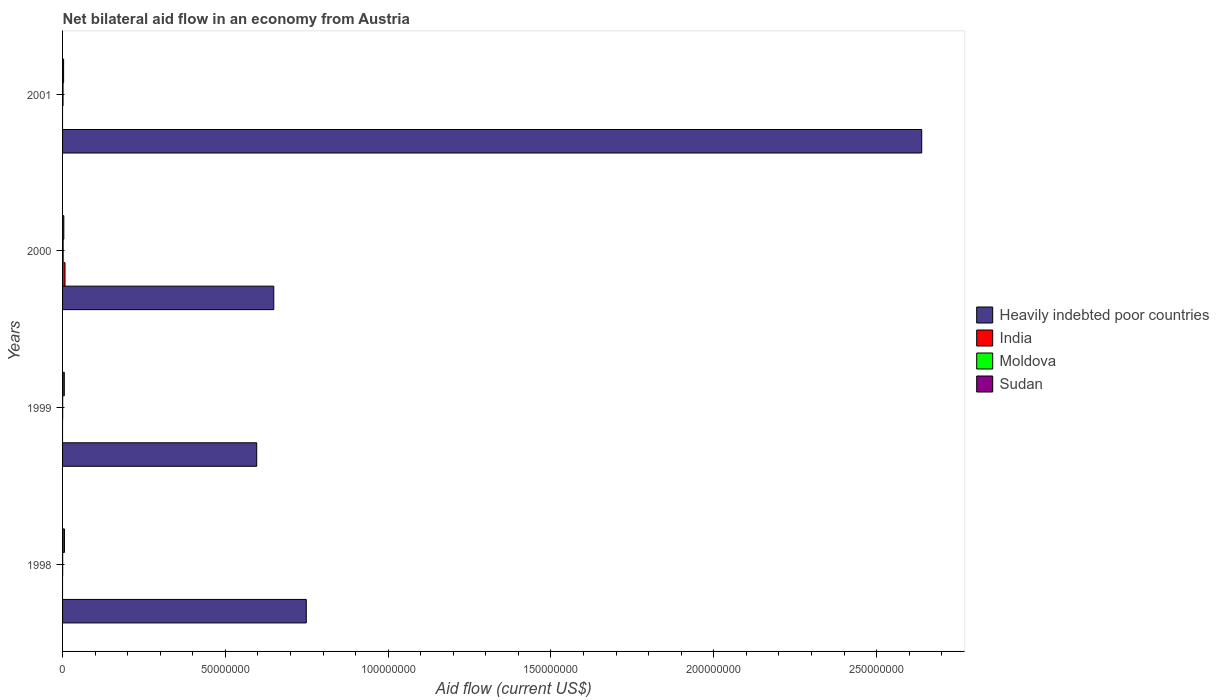How many groups of bars are there?
Your answer should be compact. 4. How many bars are there on the 2nd tick from the bottom?
Keep it short and to the point. 3. What is the net bilateral aid flow in Sudan in 1999?
Give a very brief answer. 5.30e+05. Across all years, what is the maximum net bilateral aid flow in Sudan?
Offer a very short reply. 5.80e+05. Across all years, what is the minimum net bilateral aid flow in Sudan?
Your answer should be compact. 3.20e+05. What is the total net bilateral aid flow in India in the graph?
Keep it short and to the point. 7.50e+05. What is the difference between the net bilateral aid flow in Moldova in 1998 and that in 1999?
Provide a short and direct response. 0. What is the difference between the net bilateral aid flow in Heavily indebted poor countries in 2000 and the net bilateral aid flow in India in 1999?
Your answer should be very brief. 6.49e+07. What is the average net bilateral aid flow in Moldova per year?
Your answer should be very brief. 9.75e+04. In the year 2000, what is the difference between the net bilateral aid flow in India and net bilateral aid flow in Sudan?
Keep it short and to the point. 3.60e+05. In how many years, is the net bilateral aid flow in Moldova greater than 10000000 US$?
Your response must be concise. 0. What is the ratio of the net bilateral aid flow in Moldova in 1998 to that in 2001?
Provide a succinct answer. 0.2. What is the difference between the highest and the lowest net bilateral aid flow in Sudan?
Provide a succinct answer. 2.60e+05. Is the sum of the net bilateral aid flow in Moldova in 1999 and 2001 greater than the maximum net bilateral aid flow in Heavily indebted poor countries across all years?
Offer a very short reply. No. Is it the case that in every year, the sum of the net bilateral aid flow in Sudan and net bilateral aid flow in Heavily indebted poor countries is greater than the sum of net bilateral aid flow in India and net bilateral aid flow in Moldova?
Offer a terse response. Yes. How many bars are there?
Offer a terse response. 13. What is the difference between two consecutive major ticks on the X-axis?
Ensure brevity in your answer.  5.00e+07. Are the values on the major ticks of X-axis written in scientific E-notation?
Your answer should be very brief. No. Does the graph contain any zero values?
Offer a terse response. Yes. Does the graph contain grids?
Ensure brevity in your answer.  No. Where does the legend appear in the graph?
Your answer should be compact. Center right. How are the legend labels stacked?
Offer a terse response. Vertical. What is the title of the graph?
Keep it short and to the point. Net bilateral aid flow in an economy from Austria. Does "Lower middle income" appear as one of the legend labels in the graph?
Make the answer very short. No. What is the label or title of the X-axis?
Provide a short and direct response. Aid flow (current US$). What is the label or title of the Y-axis?
Make the answer very short. Years. What is the Aid flow (current US$) in Heavily indebted poor countries in 1998?
Give a very brief answer. 7.48e+07. What is the Aid flow (current US$) of India in 1998?
Your answer should be compact. 0. What is the Aid flow (current US$) of Sudan in 1998?
Ensure brevity in your answer.  5.80e+05. What is the Aid flow (current US$) in Heavily indebted poor countries in 1999?
Keep it short and to the point. 5.96e+07. What is the Aid flow (current US$) in India in 1999?
Provide a succinct answer. 0. What is the Aid flow (current US$) of Moldova in 1999?
Keep it short and to the point. 3.00e+04. What is the Aid flow (current US$) of Sudan in 1999?
Your answer should be compact. 5.30e+05. What is the Aid flow (current US$) in Heavily indebted poor countries in 2000?
Keep it short and to the point. 6.49e+07. What is the Aid flow (current US$) of India in 2000?
Your answer should be compact. 7.50e+05. What is the Aid flow (current US$) of Moldova in 2000?
Ensure brevity in your answer.  1.80e+05. What is the Aid flow (current US$) of Sudan in 2000?
Offer a very short reply. 3.90e+05. What is the Aid flow (current US$) of Heavily indebted poor countries in 2001?
Your answer should be very brief. 2.64e+08. What is the Aid flow (current US$) of Sudan in 2001?
Provide a succinct answer. 3.20e+05. Across all years, what is the maximum Aid flow (current US$) of Heavily indebted poor countries?
Your answer should be compact. 2.64e+08. Across all years, what is the maximum Aid flow (current US$) of India?
Offer a terse response. 7.50e+05. Across all years, what is the maximum Aid flow (current US$) of Sudan?
Provide a short and direct response. 5.80e+05. Across all years, what is the minimum Aid flow (current US$) of Heavily indebted poor countries?
Provide a short and direct response. 5.96e+07. Across all years, what is the minimum Aid flow (current US$) in India?
Offer a very short reply. 0. Across all years, what is the minimum Aid flow (current US$) of Sudan?
Ensure brevity in your answer.  3.20e+05. What is the total Aid flow (current US$) in Heavily indebted poor countries in the graph?
Offer a terse response. 4.63e+08. What is the total Aid flow (current US$) of India in the graph?
Ensure brevity in your answer.  7.50e+05. What is the total Aid flow (current US$) of Sudan in the graph?
Keep it short and to the point. 1.82e+06. What is the difference between the Aid flow (current US$) of Heavily indebted poor countries in 1998 and that in 1999?
Your answer should be very brief. 1.52e+07. What is the difference between the Aid flow (current US$) in Moldova in 1998 and that in 1999?
Provide a succinct answer. 0. What is the difference between the Aid flow (current US$) in Heavily indebted poor countries in 1998 and that in 2000?
Make the answer very short. 9.98e+06. What is the difference between the Aid flow (current US$) of Moldova in 1998 and that in 2000?
Your answer should be very brief. -1.50e+05. What is the difference between the Aid flow (current US$) in Heavily indebted poor countries in 1998 and that in 2001?
Your answer should be very brief. -1.89e+08. What is the difference between the Aid flow (current US$) in Moldova in 1998 and that in 2001?
Ensure brevity in your answer.  -1.20e+05. What is the difference between the Aid flow (current US$) in Heavily indebted poor countries in 1999 and that in 2000?
Offer a very short reply. -5.24e+06. What is the difference between the Aid flow (current US$) in Heavily indebted poor countries in 1999 and that in 2001?
Offer a very short reply. -2.04e+08. What is the difference between the Aid flow (current US$) in Moldova in 1999 and that in 2001?
Your answer should be compact. -1.20e+05. What is the difference between the Aid flow (current US$) in Heavily indebted poor countries in 2000 and that in 2001?
Offer a very short reply. -1.99e+08. What is the difference between the Aid flow (current US$) of Moldova in 2000 and that in 2001?
Keep it short and to the point. 3.00e+04. What is the difference between the Aid flow (current US$) of Heavily indebted poor countries in 1998 and the Aid flow (current US$) of Moldova in 1999?
Keep it short and to the point. 7.48e+07. What is the difference between the Aid flow (current US$) of Heavily indebted poor countries in 1998 and the Aid flow (current US$) of Sudan in 1999?
Make the answer very short. 7.43e+07. What is the difference between the Aid flow (current US$) of Moldova in 1998 and the Aid flow (current US$) of Sudan in 1999?
Make the answer very short. -5.00e+05. What is the difference between the Aid flow (current US$) of Heavily indebted poor countries in 1998 and the Aid flow (current US$) of India in 2000?
Ensure brevity in your answer.  7.41e+07. What is the difference between the Aid flow (current US$) of Heavily indebted poor countries in 1998 and the Aid flow (current US$) of Moldova in 2000?
Offer a very short reply. 7.47e+07. What is the difference between the Aid flow (current US$) of Heavily indebted poor countries in 1998 and the Aid flow (current US$) of Sudan in 2000?
Your answer should be compact. 7.45e+07. What is the difference between the Aid flow (current US$) of Moldova in 1998 and the Aid flow (current US$) of Sudan in 2000?
Keep it short and to the point. -3.60e+05. What is the difference between the Aid flow (current US$) in Heavily indebted poor countries in 1998 and the Aid flow (current US$) in Moldova in 2001?
Your answer should be very brief. 7.47e+07. What is the difference between the Aid flow (current US$) of Heavily indebted poor countries in 1998 and the Aid flow (current US$) of Sudan in 2001?
Your response must be concise. 7.45e+07. What is the difference between the Aid flow (current US$) in Moldova in 1998 and the Aid flow (current US$) in Sudan in 2001?
Give a very brief answer. -2.90e+05. What is the difference between the Aid flow (current US$) in Heavily indebted poor countries in 1999 and the Aid flow (current US$) in India in 2000?
Ensure brevity in your answer.  5.89e+07. What is the difference between the Aid flow (current US$) of Heavily indebted poor countries in 1999 and the Aid flow (current US$) of Moldova in 2000?
Your answer should be compact. 5.94e+07. What is the difference between the Aid flow (current US$) in Heavily indebted poor countries in 1999 and the Aid flow (current US$) in Sudan in 2000?
Provide a short and direct response. 5.92e+07. What is the difference between the Aid flow (current US$) of Moldova in 1999 and the Aid flow (current US$) of Sudan in 2000?
Offer a terse response. -3.60e+05. What is the difference between the Aid flow (current US$) of Heavily indebted poor countries in 1999 and the Aid flow (current US$) of Moldova in 2001?
Your answer should be very brief. 5.95e+07. What is the difference between the Aid flow (current US$) of Heavily indebted poor countries in 1999 and the Aid flow (current US$) of Sudan in 2001?
Your response must be concise. 5.93e+07. What is the difference between the Aid flow (current US$) in Moldova in 1999 and the Aid flow (current US$) in Sudan in 2001?
Your response must be concise. -2.90e+05. What is the difference between the Aid flow (current US$) of Heavily indebted poor countries in 2000 and the Aid flow (current US$) of Moldova in 2001?
Provide a short and direct response. 6.47e+07. What is the difference between the Aid flow (current US$) of Heavily indebted poor countries in 2000 and the Aid flow (current US$) of Sudan in 2001?
Make the answer very short. 6.46e+07. What is the difference between the Aid flow (current US$) of India in 2000 and the Aid flow (current US$) of Moldova in 2001?
Ensure brevity in your answer.  6.00e+05. What is the difference between the Aid flow (current US$) in Moldova in 2000 and the Aid flow (current US$) in Sudan in 2001?
Give a very brief answer. -1.40e+05. What is the average Aid flow (current US$) in Heavily indebted poor countries per year?
Your answer should be compact. 1.16e+08. What is the average Aid flow (current US$) in India per year?
Your answer should be compact. 1.88e+05. What is the average Aid flow (current US$) in Moldova per year?
Provide a short and direct response. 9.75e+04. What is the average Aid flow (current US$) of Sudan per year?
Your response must be concise. 4.55e+05. In the year 1998, what is the difference between the Aid flow (current US$) in Heavily indebted poor countries and Aid flow (current US$) in Moldova?
Provide a short and direct response. 7.48e+07. In the year 1998, what is the difference between the Aid flow (current US$) in Heavily indebted poor countries and Aid flow (current US$) in Sudan?
Provide a succinct answer. 7.43e+07. In the year 1998, what is the difference between the Aid flow (current US$) in Moldova and Aid flow (current US$) in Sudan?
Provide a short and direct response. -5.50e+05. In the year 1999, what is the difference between the Aid flow (current US$) in Heavily indebted poor countries and Aid flow (current US$) in Moldova?
Offer a terse response. 5.96e+07. In the year 1999, what is the difference between the Aid flow (current US$) in Heavily indebted poor countries and Aid flow (current US$) in Sudan?
Give a very brief answer. 5.91e+07. In the year 1999, what is the difference between the Aid flow (current US$) in Moldova and Aid flow (current US$) in Sudan?
Your answer should be compact. -5.00e+05. In the year 2000, what is the difference between the Aid flow (current US$) in Heavily indebted poor countries and Aid flow (current US$) in India?
Provide a short and direct response. 6.41e+07. In the year 2000, what is the difference between the Aid flow (current US$) in Heavily indebted poor countries and Aid flow (current US$) in Moldova?
Provide a short and direct response. 6.47e+07. In the year 2000, what is the difference between the Aid flow (current US$) of Heavily indebted poor countries and Aid flow (current US$) of Sudan?
Offer a terse response. 6.45e+07. In the year 2000, what is the difference between the Aid flow (current US$) of India and Aid flow (current US$) of Moldova?
Your answer should be very brief. 5.70e+05. In the year 2001, what is the difference between the Aid flow (current US$) in Heavily indebted poor countries and Aid flow (current US$) in Moldova?
Provide a succinct answer. 2.64e+08. In the year 2001, what is the difference between the Aid flow (current US$) in Heavily indebted poor countries and Aid flow (current US$) in Sudan?
Keep it short and to the point. 2.64e+08. In the year 2001, what is the difference between the Aid flow (current US$) of Moldova and Aid flow (current US$) of Sudan?
Keep it short and to the point. -1.70e+05. What is the ratio of the Aid flow (current US$) in Heavily indebted poor countries in 1998 to that in 1999?
Your answer should be compact. 1.26. What is the ratio of the Aid flow (current US$) in Moldova in 1998 to that in 1999?
Offer a terse response. 1. What is the ratio of the Aid flow (current US$) in Sudan in 1998 to that in 1999?
Keep it short and to the point. 1.09. What is the ratio of the Aid flow (current US$) of Heavily indebted poor countries in 1998 to that in 2000?
Provide a short and direct response. 1.15. What is the ratio of the Aid flow (current US$) in Sudan in 1998 to that in 2000?
Your answer should be compact. 1.49. What is the ratio of the Aid flow (current US$) in Heavily indebted poor countries in 1998 to that in 2001?
Provide a short and direct response. 0.28. What is the ratio of the Aid flow (current US$) in Sudan in 1998 to that in 2001?
Your answer should be very brief. 1.81. What is the ratio of the Aid flow (current US$) in Heavily indebted poor countries in 1999 to that in 2000?
Provide a succinct answer. 0.92. What is the ratio of the Aid flow (current US$) in Moldova in 1999 to that in 2000?
Provide a short and direct response. 0.17. What is the ratio of the Aid flow (current US$) of Sudan in 1999 to that in 2000?
Ensure brevity in your answer.  1.36. What is the ratio of the Aid flow (current US$) of Heavily indebted poor countries in 1999 to that in 2001?
Make the answer very short. 0.23. What is the ratio of the Aid flow (current US$) in Sudan in 1999 to that in 2001?
Offer a very short reply. 1.66. What is the ratio of the Aid flow (current US$) of Heavily indebted poor countries in 2000 to that in 2001?
Offer a very short reply. 0.25. What is the ratio of the Aid flow (current US$) in Moldova in 2000 to that in 2001?
Provide a short and direct response. 1.2. What is the ratio of the Aid flow (current US$) in Sudan in 2000 to that in 2001?
Provide a succinct answer. 1.22. What is the difference between the highest and the second highest Aid flow (current US$) of Heavily indebted poor countries?
Ensure brevity in your answer.  1.89e+08. What is the difference between the highest and the lowest Aid flow (current US$) in Heavily indebted poor countries?
Provide a succinct answer. 2.04e+08. What is the difference between the highest and the lowest Aid flow (current US$) of India?
Your response must be concise. 7.50e+05. What is the difference between the highest and the lowest Aid flow (current US$) in Sudan?
Provide a short and direct response. 2.60e+05. 